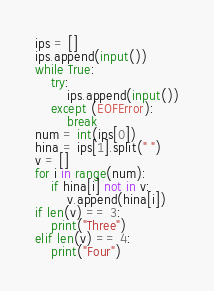<code> <loc_0><loc_0><loc_500><loc_500><_Python_>ips = []
ips.append(input())
while True:
    try:
        ips.append(input())
    except (EOFError):
        break
num = int(ips[0])
hina = ips[1].split(" ")
v = []
for i in range(num):
    if hina[i] not in v:
        v.append(hina[i])
if len(v) == 3:
    print("Three")
elif len(v) == 4:
    print("Four")</code> 